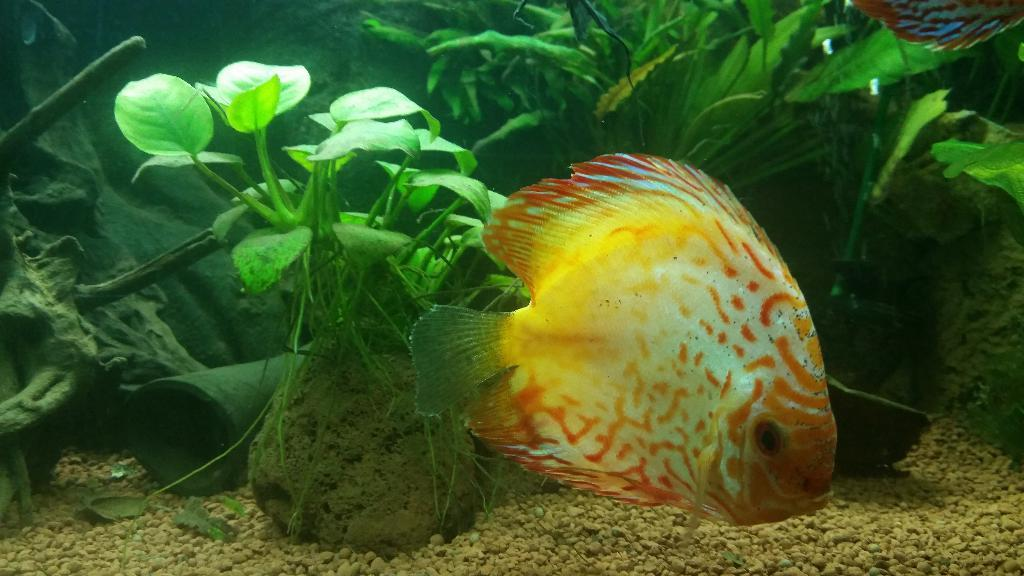What animals can be seen in the water in the image? There are two fishes in the water in the image. What can be seen behind the fish in the image? Plants and stones are visible behind the fish in the image. Are there any other objects or features visible behind the fish? Yes, there are other items visible behind the fish. What type of sheet is being used by the minister in the image? There is no minister or sheet present in the image; it features two fishes in the water with plants and stones visible behind them. 